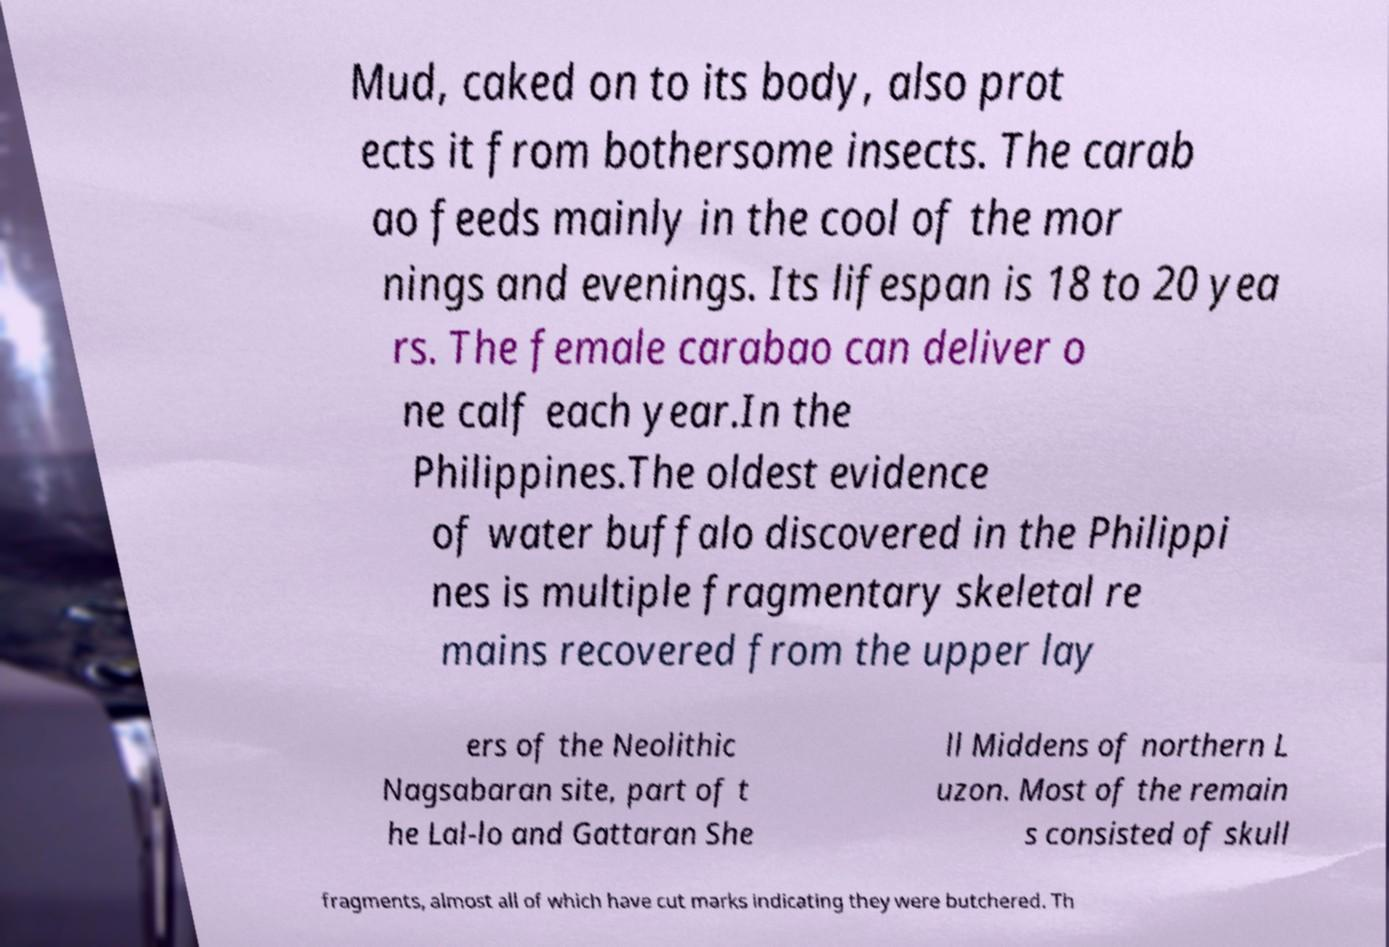Could you extract and type out the text from this image? Mud, caked on to its body, also prot ects it from bothersome insects. The carab ao feeds mainly in the cool of the mor nings and evenings. Its lifespan is 18 to 20 yea rs. The female carabao can deliver o ne calf each year.In the Philippines.The oldest evidence of water buffalo discovered in the Philippi nes is multiple fragmentary skeletal re mains recovered from the upper lay ers of the Neolithic Nagsabaran site, part of t he Lal-lo and Gattaran She ll Middens of northern L uzon. Most of the remain s consisted of skull fragments, almost all of which have cut marks indicating they were butchered. Th 